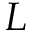<formula> <loc_0><loc_0><loc_500><loc_500>L</formula> 